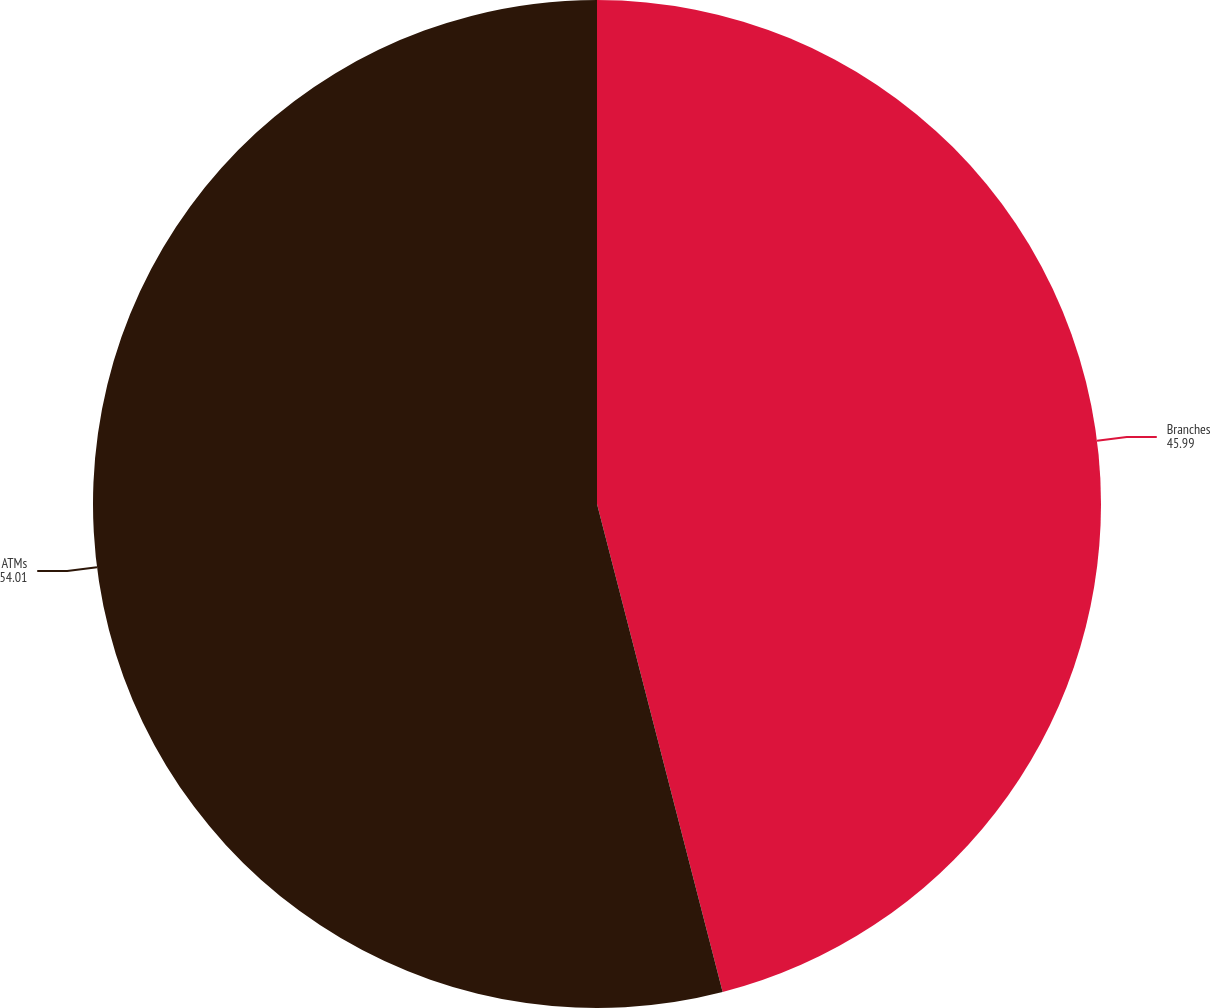Convert chart to OTSL. <chart><loc_0><loc_0><loc_500><loc_500><pie_chart><fcel>Branches<fcel>ATMs<nl><fcel>45.99%<fcel>54.01%<nl></chart> 